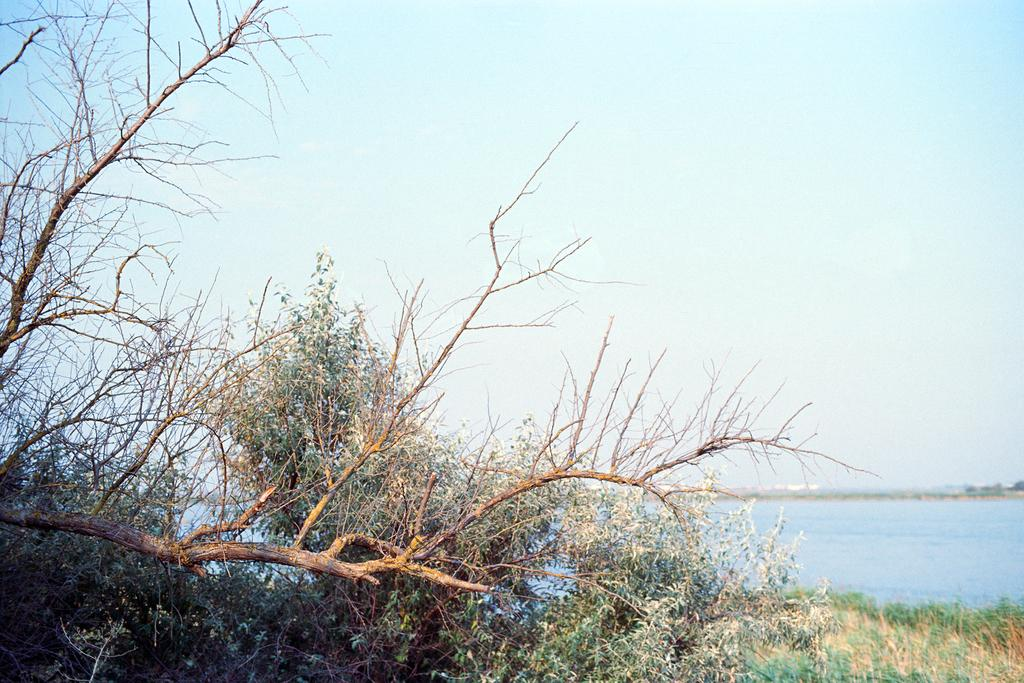What type of vegetation can be seen in the image? There are branches and trees in the image. What is the ground covered with in the image? There is grass in the image. What natural element is visible in the image? There is water visible in the image. What is visible in the background of the image? The sky is visible in the image. Where is the sofa located in the image? There is no sofa present in the image. What type of tooth can be seen in the image? There are no teeth present in the image. 